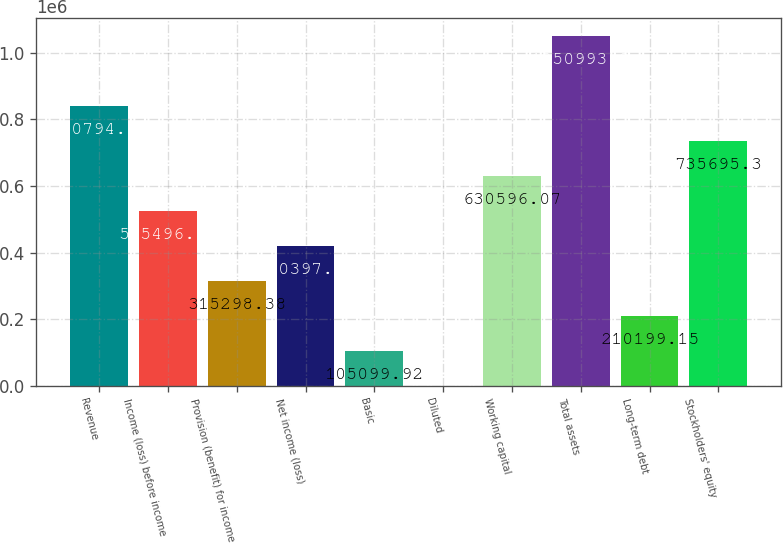Convert chart. <chart><loc_0><loc_0><loc_500><loc_500><bar_chart><fcel>Revenue<fcel>Income (loss) before income<fcel>Provision (benefit) for income<fcel>Net income (loss)<fcel>Basic<fcel>Diluted<fcel>Working capital<fcel>Total assets<fcel>Long-term debt<fcel>Stockholders' equity<nl><fcel>840795<fcel>525497<fcel>315298<fcel>420398<fcel>105100<fcel>0.69<fcel>630596<fcel>1.05099e+06<fcel>210199<fcel>735695<nl></chart> 